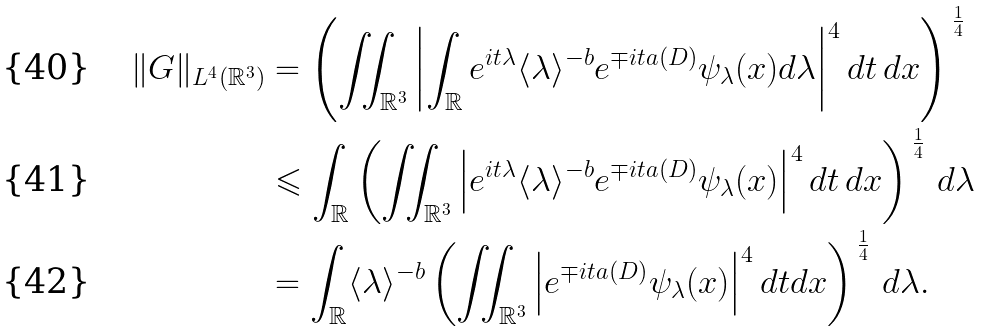<formula> <loc_0><loc_0><loc_500><loc_500>\| { G } \| _ { L ^ { 4 } ( \mathbb { R } ^ { 3 } ) } & = \left ( \iint _ { \mathbb { R } ^ { 3 } } \left | \int _ { \mathbb { R } } e ^ { i t \lambda } \langle \lambda \rangle ^ { - b } e ^ { { \mp } i t a ( D ) } \psi _ { \lambda } ( x ) d \lambda \right | ^ { 4 } d t \, d x \right ) ^ { \, \frac { 1 } { 4 } } \\ & \leqslant \int _ { \mathbb { R } } \left ( \iint _ { \mathbb { R } ^ { 3 } } \left | e ^ { i t \lambda } \langle \lambda \rangle ^ { - b } e ^ { { \mp } i t a ( D ) } \psi _ { \lambda } ( x ) \right | ^ { 4 } d t \, d x \right ) ^ { \, \frac { 1 } { 4 } } \, d \lambda \\ & = \int _ { \mathbb { R } } \langle \lambda \rangle ^ { - b } \left ( \iint _ { \mathbb { R } ^ { 3 } } \left | e ^ { { \mp } i t a ( D ) } \psi _ { \lambda } ( x ) \right | ^ { 4 } d t d x \right ) ^ { \, \frac { 1 } { 4 } } \, d \lambda .</formula> 